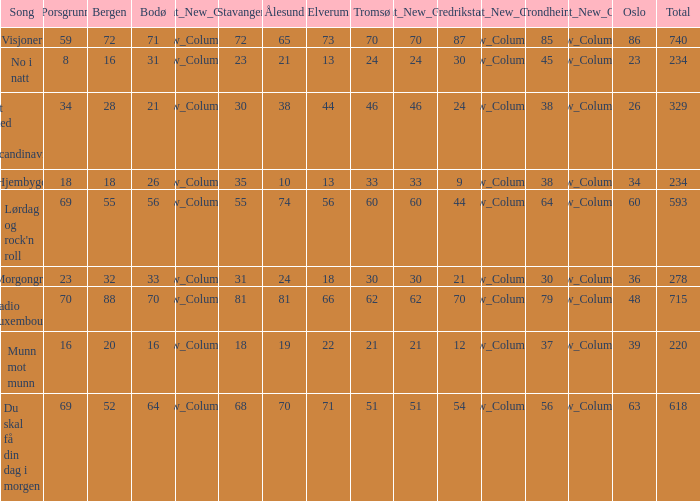When bergen is 88, what is the alesund? 81.0. 